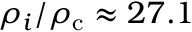<formula> <loc_0><loc_0><loc_500><loc_500>\rho _ { i } / \rho _ { c } \approx 2 7 . 1</formula> 